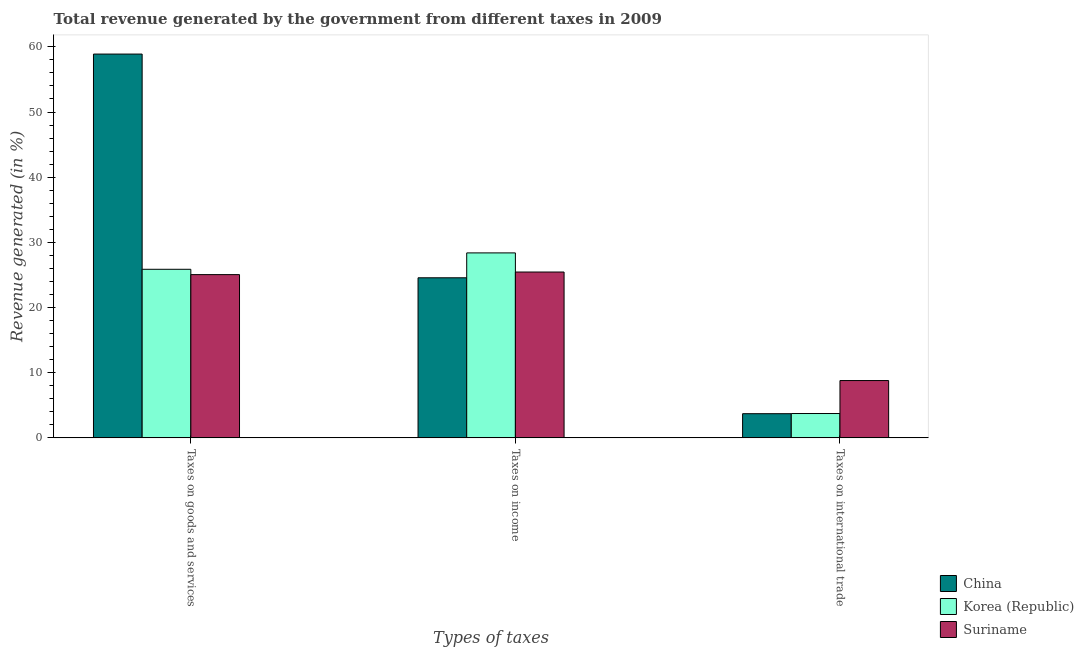How many different coloured bars are there?
Ensure brevity in your answer.  3. How many groups of bars are there?
Provide a short and direct response. 3. Are the number of bars on each tick of the X-axis equal?
Provide a short and direct response. Yes. What is the label of the 1st group of bars from the left?
Make the answer very short. Taxes on goods and services. What is the percentage of revenue generated by taxes on goods and services in Suriname?
Offer a very short reply. 25.05. Across all countries, what is the maximum percentage of revenue generated by taxes on income?
Ensure brevity in your answer.  28.38. Across all countries, what is the minimum percentage of revenue generated by tax on international trade?
Your answer should be compact. 3.71. In which country was the percentage of revenue generated by taxes on income maximum?
Make the answer very short. Korea (Republic). What is the total percentage of revenue generated by tax on international trade in the graph?
Make the answer very short. 16.24. What is the difference between the percentage of revenue generated by taxes on income in Korea (Republic) and that in China?
Offer a very short reply. 3.82. What is the difference between the percentage of revenue generated by taxes on income in China and the percentage of revenue generated by tax on international trade in Suriname?
Your response must be concise. 15.77. What is the average percentage of revenue generated by taxes on goods and services per country?
Offer a terse response. 36.6. What is the difference between the percentage of revenue generated by taxes on goods and services and percentage of revenue generated by tax on international trade in Suriname?
Keep it short and to the point. 16.26. In how many countries, is the percentage of revenue generated by taxes on goods and services greater than 20 %?
Keep it short and to the point. 3. What is the ratio of the percentage of revenue generated by taxes on goods and services in Suriname to that in China?
Offer a terse response. 0.43. Is the difference between the percentage of revenue generated by taxes on income in Korea (Republic) and Suriname greater than the difference between the percentage of revenue generated by tax on international trade in Korea (Republic) and Suriname?
Make the answer very short. Yes. What is the difference between the highest and the second highest percentage of revenue generated by taxes on goods and services?
Offer a terse response. 33.03. What is the difference between the highest and the lowest percentage of revenue generated by tax on international trade?
Provide a short and direct response. 5.09. Is the sum of the percentage of revenue generated by taxes on goods and services in China and Korea (Republic) greater than the maximum percentage of revenue generated by tax on international trade across all countries?
Your answer should be very brief. Yes. What does the 3rd bar from the left in Taxes on international trade represents?
Make the answer very short. Suriname. Is it the case that in every country, the sum of the percentage of revenue generated by taxes on goods and services and percentage of revenue generated by taxes on income is greater than the percentage of revenue generated by tax on international trade?
Offer a very short reply. Yes. Are all the bars in the graph horizontal?
Ensure brevity in your answer.  No. Are the values on the major ticks of Y-axis written in scientific E-notation?
Provide a succinct answer. No. Where does the legend appear in the graph?
Offer a terse response. Bottom right. How are the legend labels stacked?
Offer a very short reply. Vertical. What is the title of the graph?
Offer a terse response. Total revenue generated by the government from different taxes in 2009. What is the label or title of the X-axis?
Your response must be concise. Types of taxes. What is the label or title of the Y-axis?
Ensure brevity in your answer.  Revenue generated (in %). What is the Revenue generated (in %) of China in Taxes on goods and services?
Your response must be concise. 58.89. What is the Revenue generated (in %) in Korea (Republic) in Taxes on goods and services?
Offer a terse response. 25.87. What is the Revenue generated (in %) in Suriname in Taxes on goods and services?
Your response must be concise. 25.05. What is the Revenue generated (in %) of China in Taxes on income?
Make the answer very short. 24.56. What is the Revenue generated (in %) in Korea (Republic) in Taxes on income?
Keep it short and to the point. 28.38. What is the Revenue generated (in %) in Suriname in Taxes on income?
Your response must be concise. 25.45. What is the Revenue generated (in %) in China in Taxes on international trade?
Provide a short and direct response. 3.71. What is the Revenue generated (in %) in Korea (Republic) in Taxes on international trade?
Your answer should be compact. 3.74. What is the Revenue generated (in %) of Suriname in Taxes on international trade?
Your answer should be compact. 8.79. Across all Types of taxes, what is the maximum Revenue generated (in %) in China?
Your answer should be compact. 58.89. Across all Types of taxes, what is the maximum Revenue generated (in %) in Korea (Republic)?
Your answer should be very brief. 28.38. Across all Types of taxes, what is the maximum Revenue generated (in %) in Suriname?
Offer a terse response. 25.45. Across all Types of taxes, what is the minimum Revenue generated (in %) in China?
Give a very brief answer. 3.71. Across all Types of taxes, what is the minimum Revenue generated (in %) in Korea (Republic)?
Your response must be concise. 3.74. Across all Types of taxes, what is the minimum Revenue generated (in %) of Suriname?
Make the answer very short. 8.79. What is the total Revenue generated (in %) in China in the graph?
Make the answer very short. 87.16. What is the total Revenue generated (in %) of Korea (Republic) in the graph?
Keep it short and to the point. 57.99. What is the total Revenue generated (in %) in Suriname in the graph?
Offer a very short reply. 59.29. What is the difference between the Revenue generated (in %) of China in Taxes on goods and services and that in Taxes on income?
Provide a succinct answer. 34.33. What is the difference between the Revenue generated (in %) in Korea (Republic) in Taxes on goods and services and that in Taxes on income?
Offer a terse response. -2.52. What is the difference between the Revenue generated (in %) in Suriname in Taxes on goods and services and that in Taxes on income?
Your answer should be very brief. -0.4. What is the difference between the Revenue generated (in %) of China in Taxes on goods and services and that in Taxes on international trade?
Make the answer very short. 55.18. What is the difference between the Revenue generated (in %) in Korea (Republic) in Taxes on goods and services and that in Taxes on international trade?
Make the answer very short. 22.13. What is the difference between the Revenue generated (in %) of Suriname in Taxes on goods and services and that in Taxes on international trade?
Keep it short and to the point. 16.26. What is the difference between the Revenue generated (in %) in China in Taxes on income and that in Taxes on international trade?
Your response must be concise. 20.86. What is the difference between the Revenue generated (in %) of Korea (Republic) in Taxes on income and that in Taxes on international trade?
Give a very brief answer. 24.65. What is the difference between the Revenue generated (in %) in Suriname in Taxes on income and that in Taxes on international trade?
Offer a terse response. 16.65. What is the difference between the Revenue generated (in %) of China in Taxes on goods and services and the Revenue generated (in %) of Korea (Republic) in Taxes on income?
Ensure brevity in your answer.  30.51. What is the difference between the Revenue generated (in %) in China in Taxes on goods and services and the Revenue generated (in %) in Suriname in Taxes on income?
Make the answer very short. 33.44. What is the difference between the Revenue generated (in %) in Korea (Republic) in Taxes on goods and services and the Revenue generated (in %) in Suriname in Taxes on income?
Offer a terse response. 0.42. What is the difference between the Revenue generated (in %) in China in Taxes on goods and services and the Revenue generated (in %) in Korea (Republic) in Taxes on international trade?
Provide a short and direct response. 55.16. What is the difference between the Revenue generated (in %) in China in Taxes on goods and services and the Revenue generated (in %) in Suriname in Taxes on international trade?
Your answer should be very brief. 50.1. What is the difference between the Revenue generated (in %) of Korea (Republic) in Taxes on goods and services and the Revenue generated (in %) of Suriname in Taxes on international trade?
Your answer should be very brief. 17.07. What is the difference between the Revenue generated (in %) of China in Taxes on income and the Revenue generated (in %) of Korea (Republic) in Taxes on international trade?
Make the answer very short. 20.83. What is the difference between the Revenue generated (in %) in China in Taxes on income and the Revenue generated (in %) in Suriname in Taxes on international trade?
Provide a succinct answer. 15.77. What is the difference between the Revenue generated (in %) of Korea (Republic) in Taxes on income and the Revenue generated (in %) of Suriname in Taxes on international trade?
Ensure brevity in your answer.  19.59. What is the average Revenue generated (in %) of China per Types of taxes?
Your response must be concise. 29.05. What is the average Revenue generated (in %) of Korea (Republic) per Types of taxes?
Your answer should be compact. 19.33. What is the average Revenue generated (in %) of Suriname per Types of taxes?
Give a very brief answer. 19.76. What is the difference between the Revenue generated (in %) in China and Revenue generated (in %) in Korea (Republic) in Taxes on goods and services?
Your response must be concise. 33.03. What is the difference between the Revenue generated (in %) in China and Revenue generated (in %) in Suriname in Taxes on goods and services?
Provide a succinct answer. 33.84. What is the difference between the Revenue generated (in %) in Korea (Republic) and Revenue generated (in %) in Suriname in Taxes on goods and services?
Your answer should be compact. 0.82. What is the difference between the Revenue generated (in %) of China and Revenue generated (in %) of Korea (Republic) in Taxes on income?
Keep it short and to the point. -3.82. What is the difference between the Revenue generated (in %) of China and Revenue generated (in %) of Suriname in Taxes on income?
Provide a succinct answer. -0.88. What is the difference between the Revenue generated (in %) in Korea (Republic) and Revenue generated (in %) in Suriname in Taxes on income?
Give a very brief answer. 2.94. What is the difference between the Revenue generated (in %) of China and Revenue generated (in %) of Korea (Republic) in Taxes on international trade?
Offer a very short reply. -0.03. What is the difference between the Revenue generated (in %) in China and Revenue generated (in %) in Suriname in Taxes on international trade?
Keep it short and to the point. -5.09. What is the difference between the Revenue generated (in %) of Korea (Republic) and Revenue generated (in %) of Suriname in Taxes on international trade?
Make the answer very short. -5.06. What is the ratio of the Revenue generated (in %) of China in Taxes on goods and services to that in Taxes on income?
Ensure brevity in your answer.  2.4. What is the ratio of the Revenue generated (in %) in Korea (Republic) in Taxes on goods and services to that in Taxes on income?
Give a very brief answer. 0.91. What is the ratio of the Revenue generated (in %) in Suriname in Taxes on goods and services to that in Taxes on income?
Keep it short and to the point. 0.98. What is the ratio of the Revenue generated (in %) of China in Taxes on goods and services to that in Taxes on international trade?
Provide a short and direct response. 15.88. What is the ratio of the Revenue generated (in %) of Korea (Republic) in Taxes on goods and services to that in Taxes on international trade?
Your response must be concise. 6.92. What is the ratio of the Revenue generated (in %) of Suriname in Taxes on goods and services to that in Taxes on international trade?
Offer a very short reply. 2.85. What is the ratio of the Revenue generated (in %) in China in Taxes on income to that in Taxes on international trade?
Offer a terse response. 6.62. What is the ratio of the Revenue generated (in %) in Korea (Republic) in Taxes on income to that in Taxes on international trade?
Your response must be concise. 7.6. What is the ratio of the Revenue generated (in %) of Suriname in Taxes on income to that in Taxes on international trade?
Give a very brief answer. 2.89. What is the difference between the highest and the second highest Revenue generated (in %) of China?
Your answer should be very brief. 34.33. What is the difference between the highest and the second highest Revenue generated (in %) of Korea (Republic)?
Make the answer very short. 2.52. What is the difference between the highest and the second highest Revenue generated (in %) in Suriname?
Provide a succinct answer. 0.4. What is the difference between the highest and the lowest Revenue generated (in %) in China?
Provide a short and direct response. 55.18. What is the difference between the highest and the lowest Revenue generated (in %) in Korea (Republic)?
Provide a succinct answer. 24.65. What is the difference between the highest and the lowest Revenue generated (in %) of Suriname?
Keep it short and to the point. 16.65. 